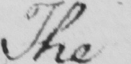Transcribe the text shown in this historical manuscript line. The 